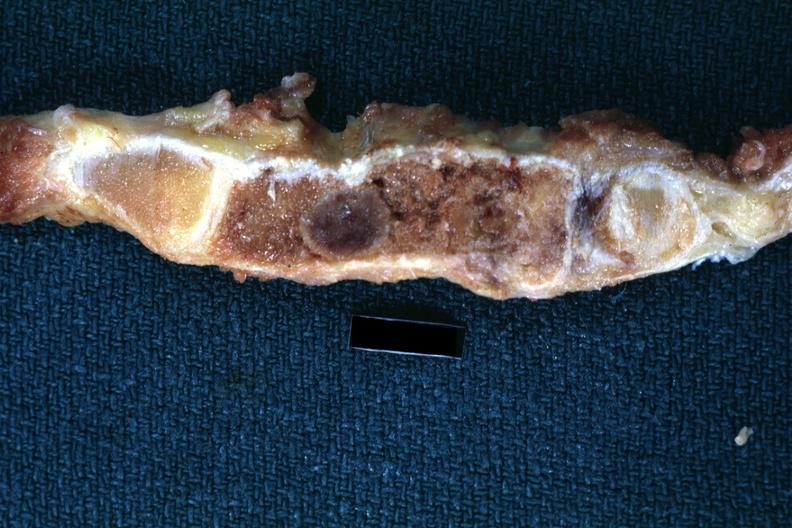does this image show fixed tissue saggital section sternum with typical plasmacytoma shown close-up very good?
Answer the question using a single word or phrase. Yes 